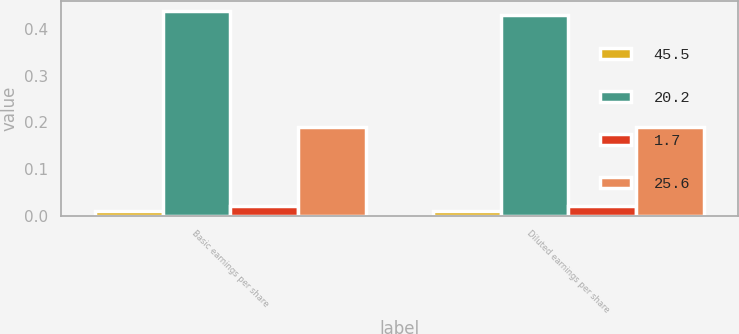Convert chart. <chart><loc_0><loc_0><loc_500><loc_500><stacked_bar_chart><ecel><fcel>Basic earnings per share<fcel>Diluted earnings per share<nl><fcel>45.5<fcel>0.01<fcel>0.01<nl><fcel>20.2<fcel>0.44<fcel>0.43<nl><fcel>1.7<fcel>0.02<fcel>0.02<nl><fcel>25.6<fcel>0.19<fcel>0.19<nl></chart> 